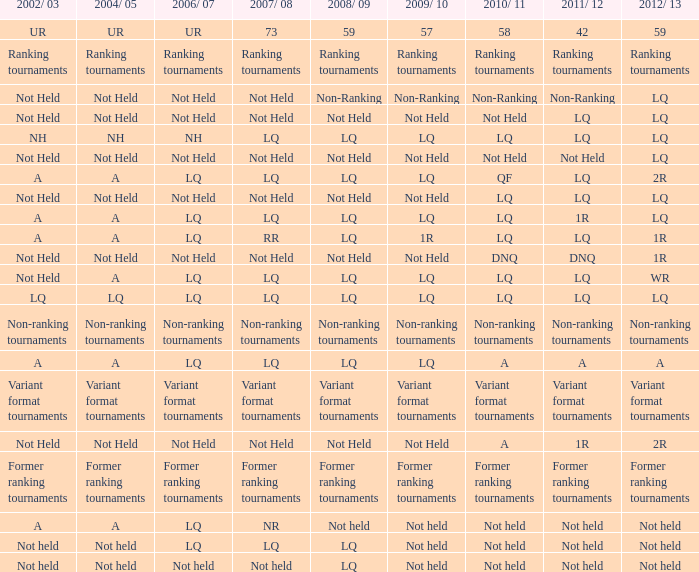Name the 2009/10 with 2011/12 of a LQ. 